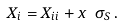<formula> <loc_0><loc_0><loc_500><loc_500>X _ { i } = X _ { i i } + x \ \sigma _ { S } \, .</formula> 